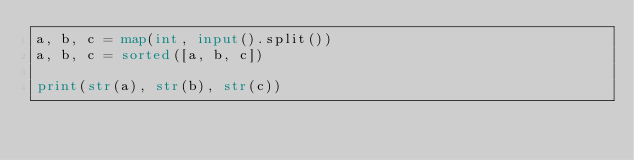Convert code to text. <code><loc_0><loc_0><loc_500><loc_500><_Python_>a, b, c = map(int, input().split())
a, b, c = sorted([a, b, c])

print(str(a), str(b), str(c))
</code> 